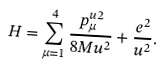Convert formula to latex. <formula><loc_0><loc_0><loc_500><loc_500>H = \sum _ { \mu = 1 } ^ { 4 } \frac { p _ { \mu } ^ { u 2 } } { 8 M u ^ { 2 } } + \frac { e ^ { 2 } } { u ^ { 2 } } .</formula> 